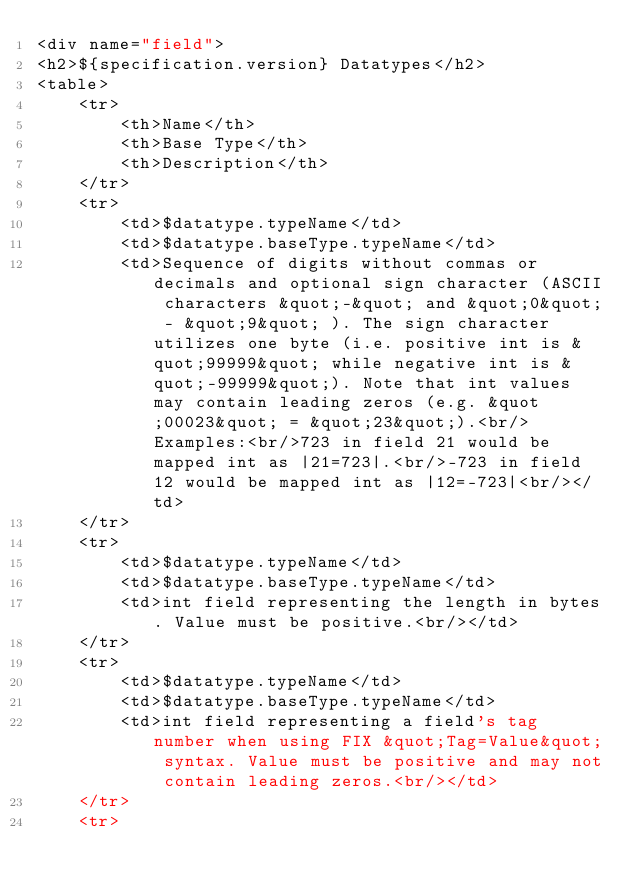<code> <loc_0><loc_0><loc_500><loc_500><_HTML_><div name="field">
<h2>${specification.version} Datatypes</h2>
<table>
    <tr>
        <th>Name</th>
        <th>Base Type</th>
        <th>Description</th>
    </tr>
    <tr>
        <td>$datatype.typeName</td>
        <td>$datatype.baseType.typeName</td>
        <td>Sequence of digits without commas or decimals and optional sign character (ASCII characters &quot;-&quot; and &quot;0&quot; - &quot;9&quot; ). The sign character utilizes one byte (i.e. positive int is &quot;99999&quot; while negative int is &quot;-99999&quot;). Note that int values may contain leading zeros (e.g. &quot;00023&quot; = &quot;23&quot;).<br/>Examples:<br/>723 in field 21 would be mapped int as |21=723|.<br/>-723 in field 12 would be mapped int as |12=-723|<br/></td>
    </tr>
    <tr>
        <td>$datatype.typeName</td>
        <td>$datatype.baseType.typeName</td>
        <td>int field representing the length in bytes. Value must be positive.<br/></td>
    </tr>
    <tr>
        <td>$datatype.typeName</td>
        <td>$datatype.baseType.typeName</td>
        <td>int field representing a field's tag number when using FIX &quot;Tag=Value&quot; syntax. Value must be positive and may not contain leading zeros.<br/></td>
    </tr>
    <tr></code> 